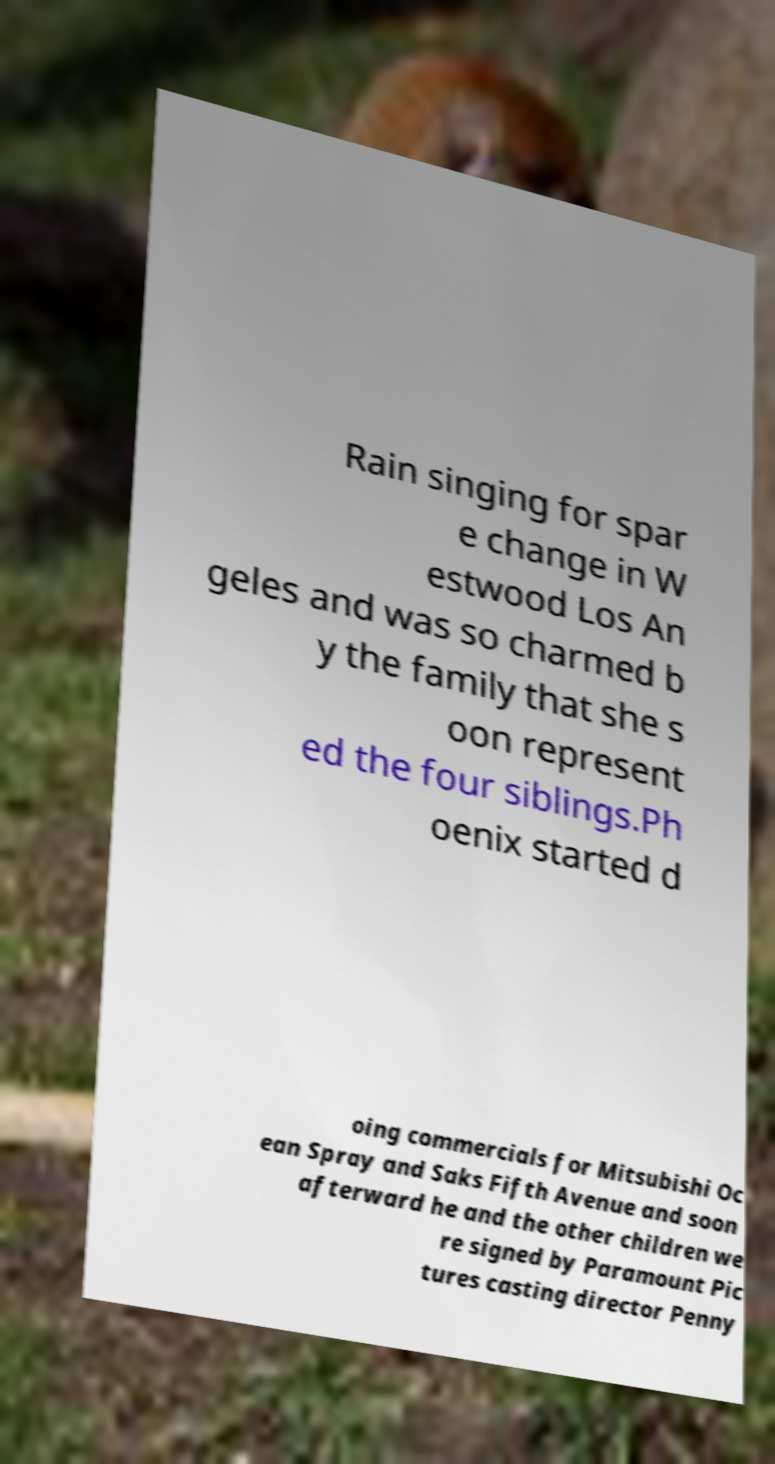There's text embedded in this image that I need extracted. Can you transcribe it verbatim? Rain singing for spar e change in W estwood Los An geles and was so charmed b y the family that she s oon represent ed the four siblings.Ph oenix started d oing commercials for Mitsubishi Oc ean Spray and Saks Fifth Avenue and soon afterward he and the other children we re signed by Paramount Pic tures casting director Penny 